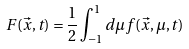<formula> <loc_0><loc_0><loc_500><loc_500>F ( \vec { x } , t ) = \frac { 1 } { 2 } \int _ { - 1 } ^ { 1 } d \mu f ( \vec { x } , \mu , t )</formula> 